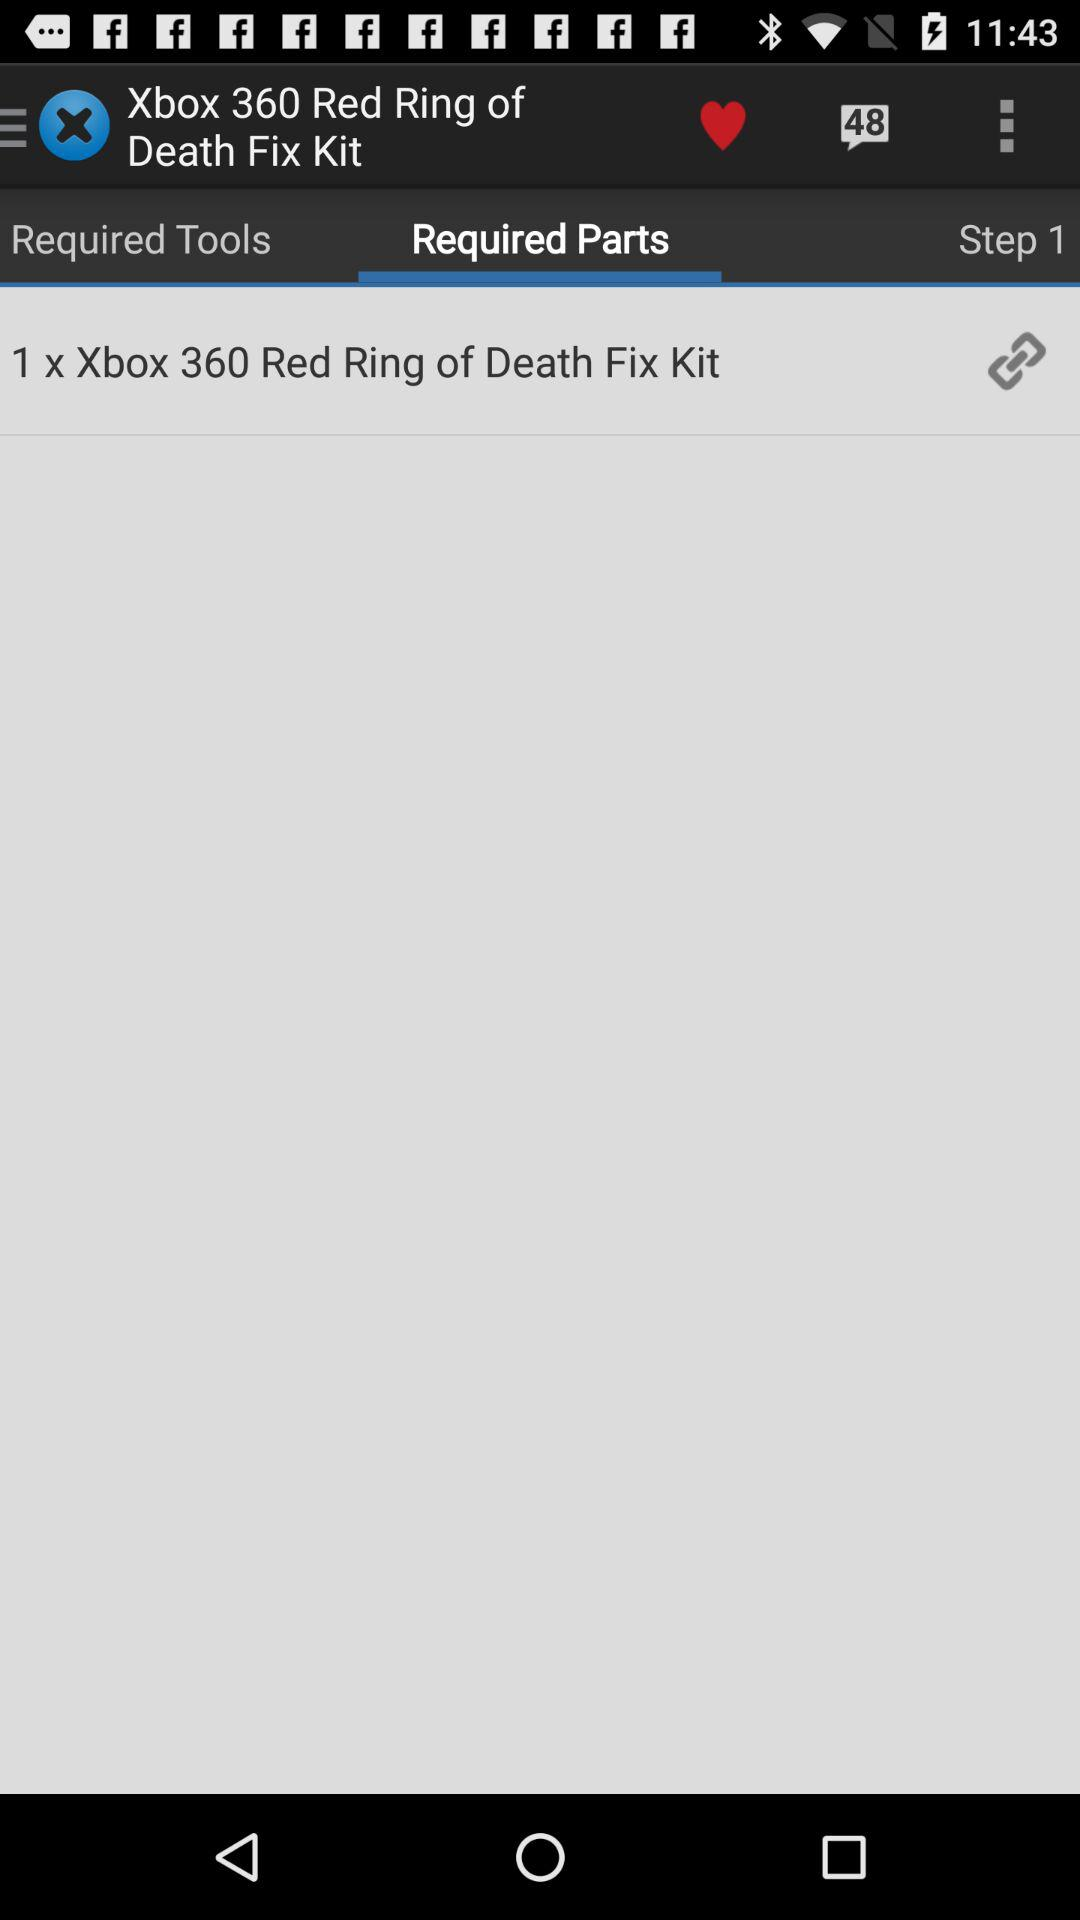Which tab is selected? The selected tab is "Required Parts". 